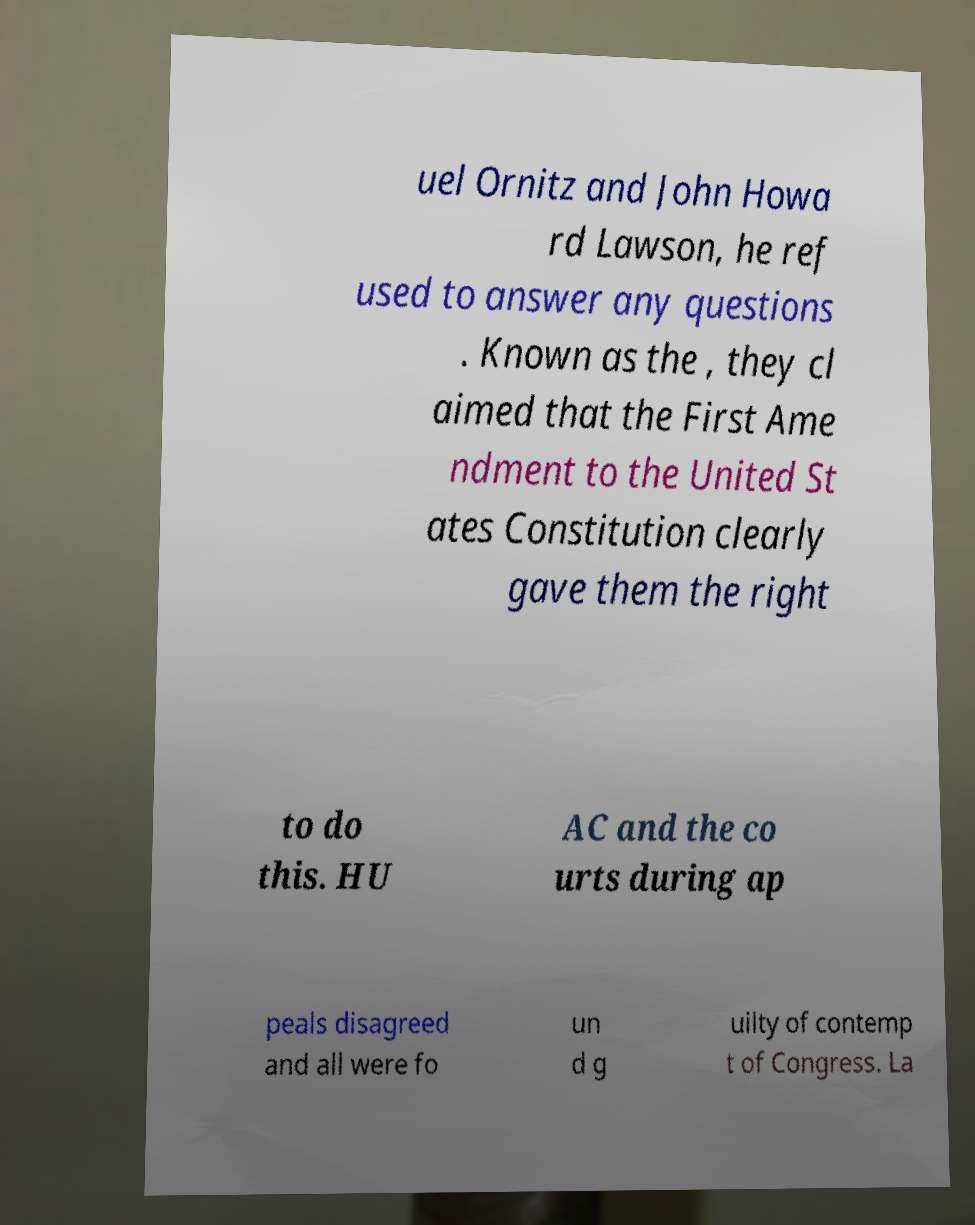Could you assist in decoding the text presented in this image and type it out clearly? uel Ornitz and John Howa rd Lawson, he ref used to answer any questions . Known as the , they cl aimed that the First Ame ndment to the United St ates Constitution clearly gave them the right to do this. HU AC and the co urts during ap peals disagreed and all were fo un d g uilty of contemp t of Congress. La 